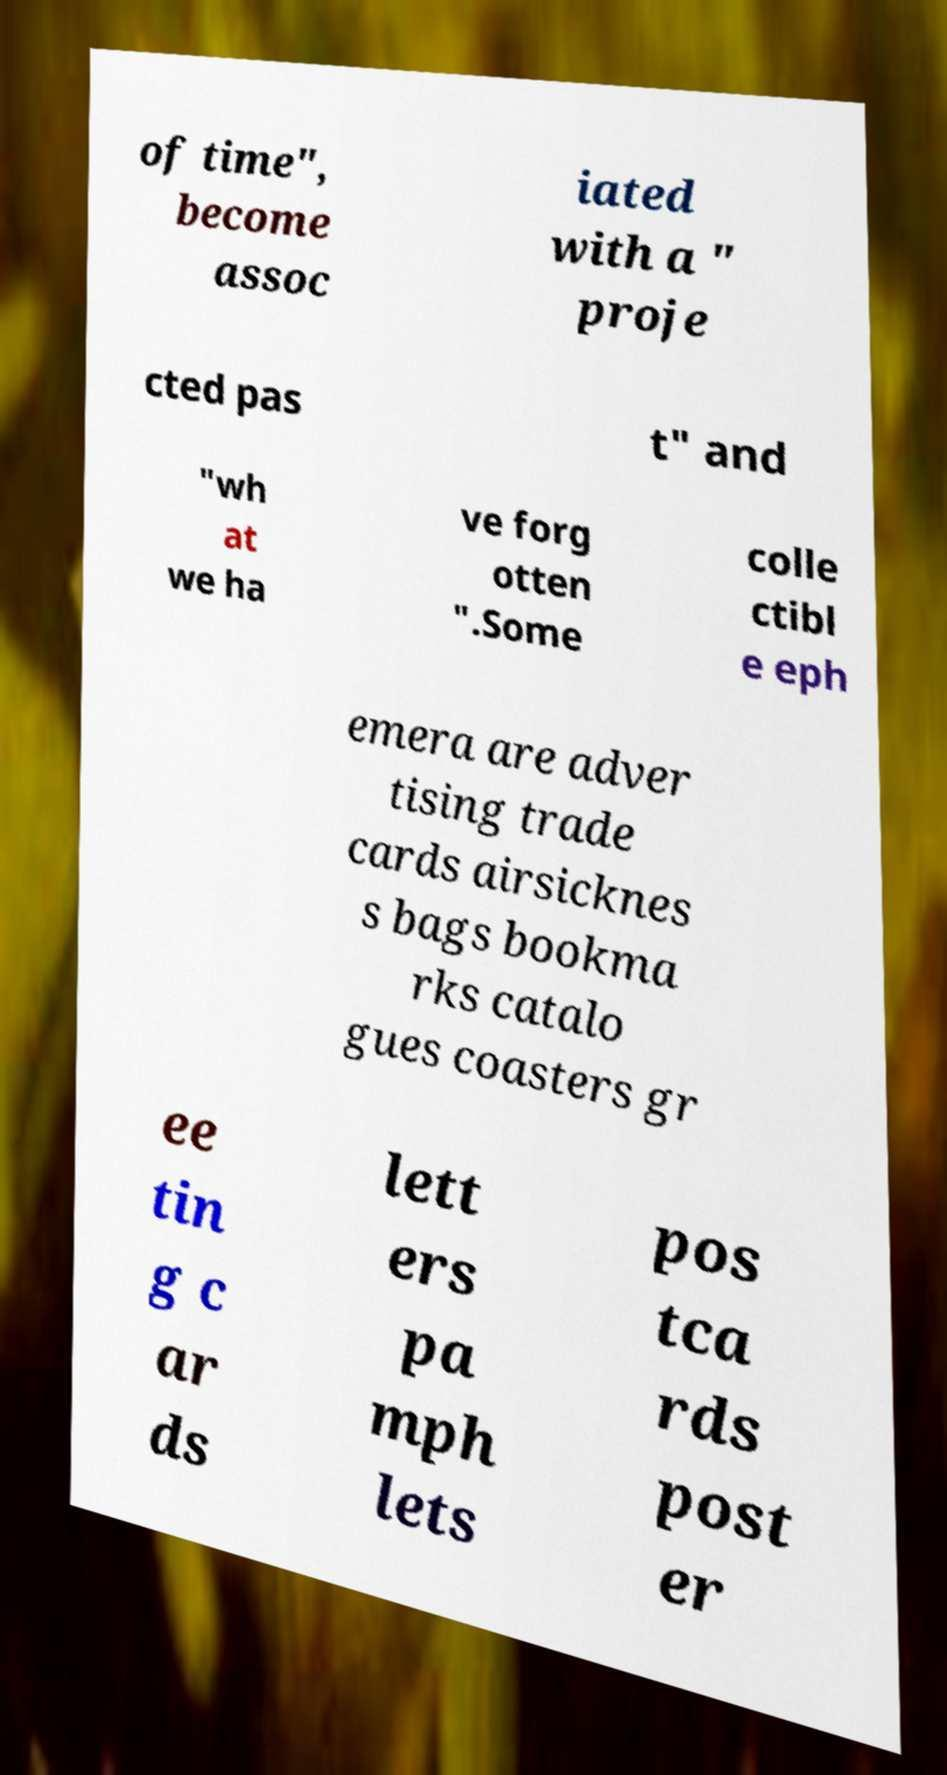Could you assist in decoding the text presented in this image and type it out clearly? of time", become assoc iated with a " proje cted pas t" and "wh at we ha ve forg otten ".Some colle ctibl e eph emera are adver tising trade cards airsicknes s bags bookma rks catalo gues coasters gr ee tin g c ar ds lett ers pa mph lets pos tca rds post er 